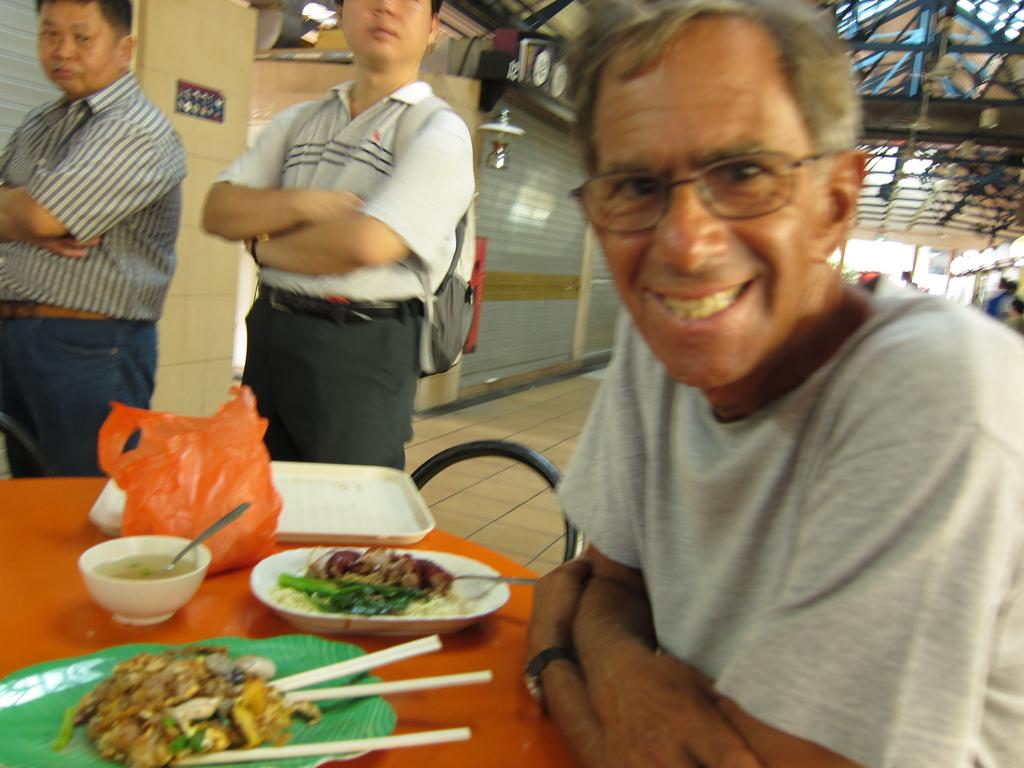What is the man in the image doing? The man is sitting in front of a table. What can be found on the table? There are food items on the table, as well as a tray and a polythene. Can you describe the background of the image? There are people, shutters, and a roof visible in the background of the image. What type of queen is sitting next to the man in the image? There is no queen present in the image; it only shows a man sitting in front of a table with food items, a tray, and a polythene on it. 